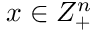<formula> <loc_0><loc_0><loc_500><loc_500>x \in Z _ { + } ^ { n }</formula> 